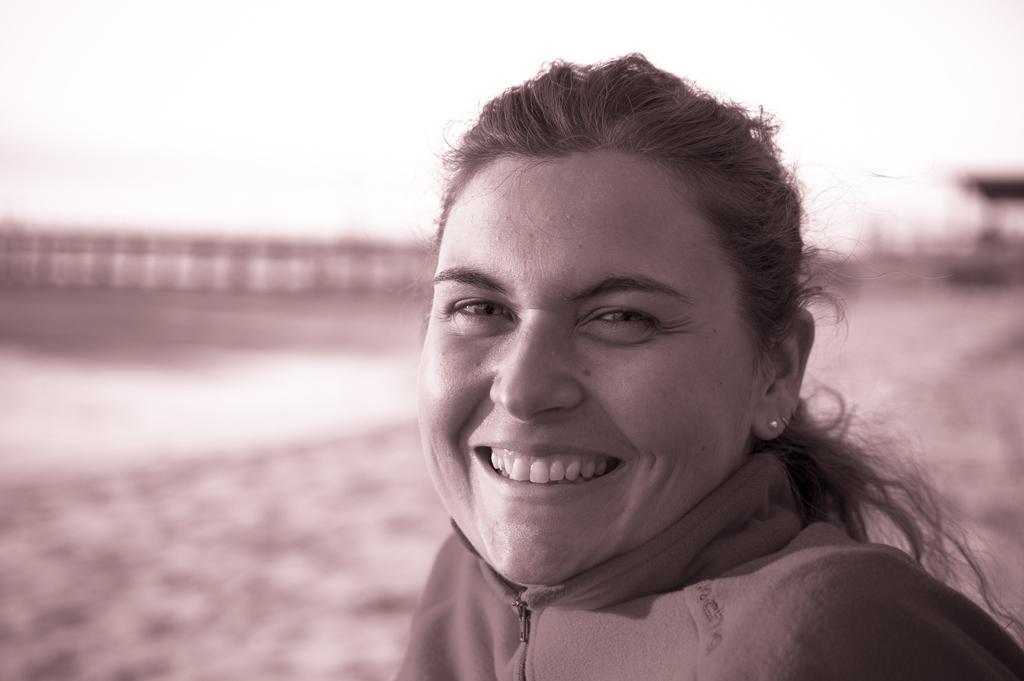How would you summarize this image in a sentence or two? This is a black and white image. We can see a lady smiling and the background is blurred. 